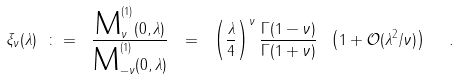Convert formula to latex. <formula><loc_0><loc_0><loc_500><loc_500>\xi _ { \nu } ( \lambda ) \ \colon = \ \frac { \text {M} ^ { ( 1 ) } _ { \nu } ( 0 , \lambda ) } { \text {M} ^ { ( 1 ) } _ { - \nu } ( 0 , \lambda ) } \ = \ \left ( \frac { \lambda } { 4 } \right ) ^ { \nu } \frac { \Gamma ( 1 - \nu ) } { \Gamma ( 1 + \nu ) } \ \left ( 1 + \mathcal { O } ( \lambda ^ { 2 } / \nu ) \right ) \ \ .</formula> 